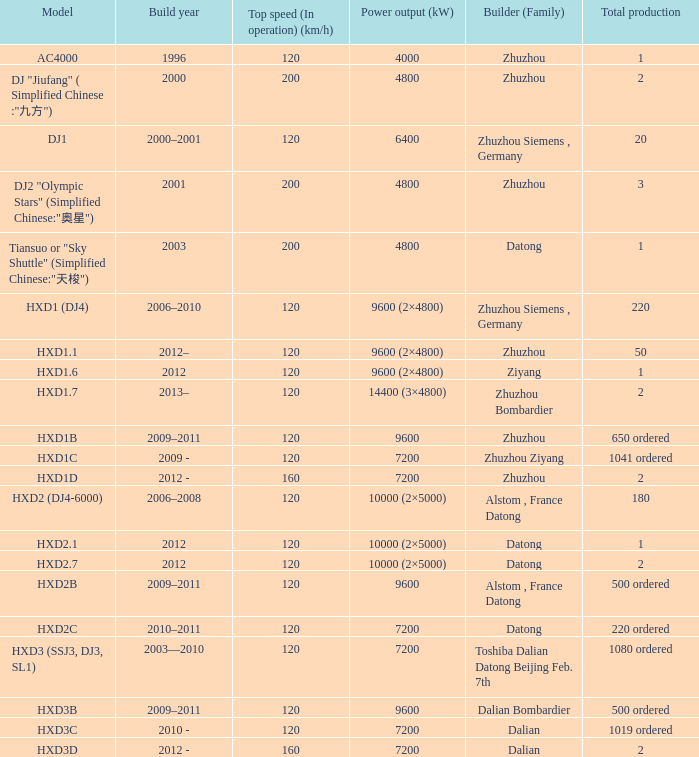What is the power production (kw) of model hxd2b? 9600.0. 